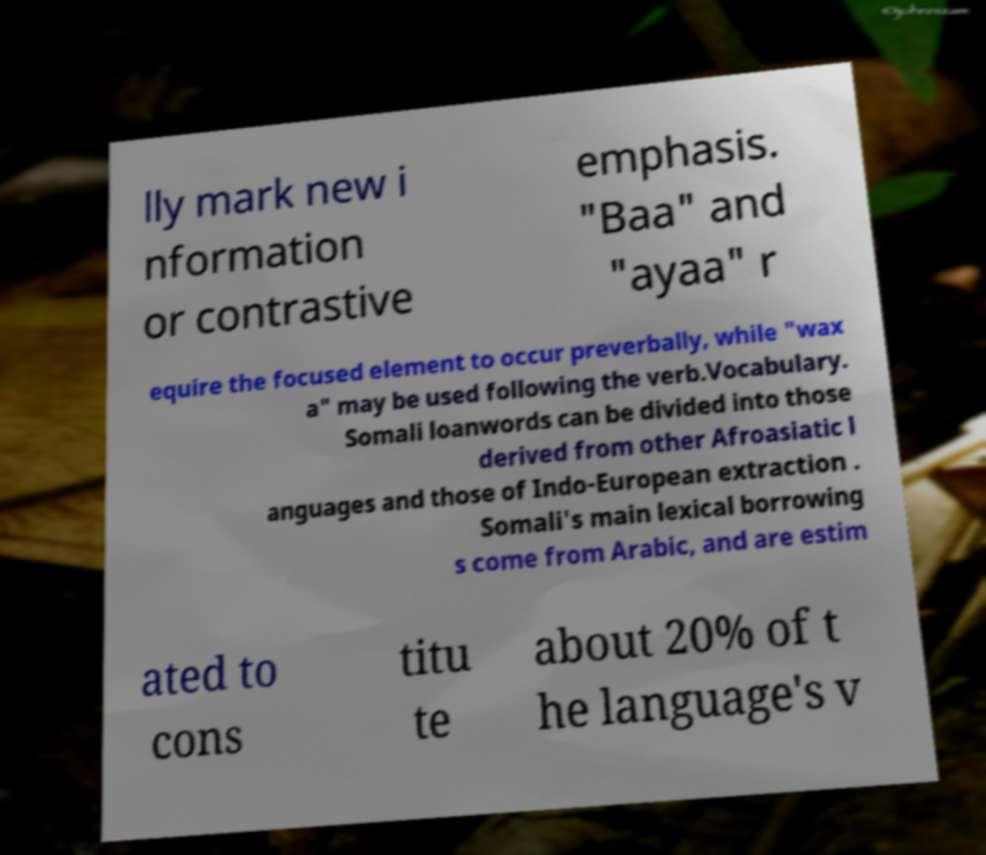I need the written content from this picture converted into text. Can you do that? lly mark new i nformation or contrastive emphasis. "Baa" and "ayaa" r equire the focused element to occur preverbally, while "wax a" may be used following the verb.Vocabulary. Somali loanwords can be divided into those derived from other Afroasiatic l anguages and those of Indo-European extraction . Somali's main lexical borrowing s come from Arabic, and are estim ated to cons titu te about 20% of t he language's v 